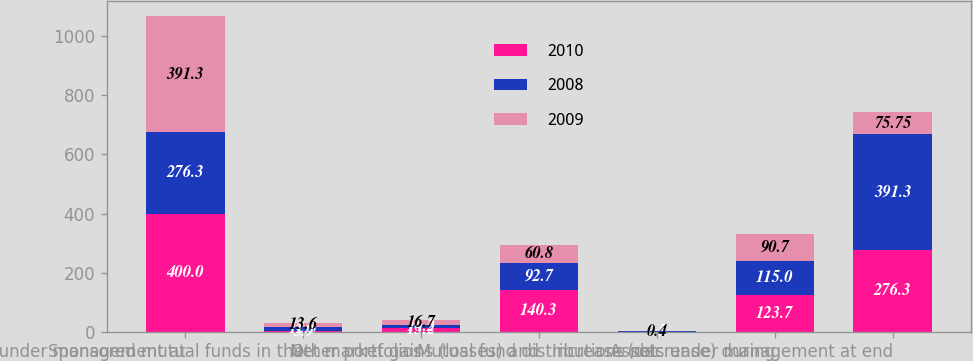<chart> <loc_0><loc_0><loc_500><loc_500><stacked_bar_chart><ecel><fcel>Assets under management at<fcel>Sponsored mutual funds in the<fcel>Other portfolios<fcel>Net market gains (losses) and<fcel>Mutual fund distributions not<fcel>Increase (decrease) during<fcel>Assets under management at end<nl><fcel>2010<fcel>400<fcel>3.9<fcel>13.2<fcel>140.3<fcel>0.5<fcel>123.7<fcel>276.3<nl><fcel>2008<fcel>276.3<fcel>12.5<fcel>10.2<fcel>92.7<fcel>0.4<fcel>115<fcel>391.3<nl><fcel>2009<fcel>391.3<fcel>13.6<fcel>16.7<fcel>60.8<fcel>0.4<fcel>90.7<fcel>75.75<nl></chart> 